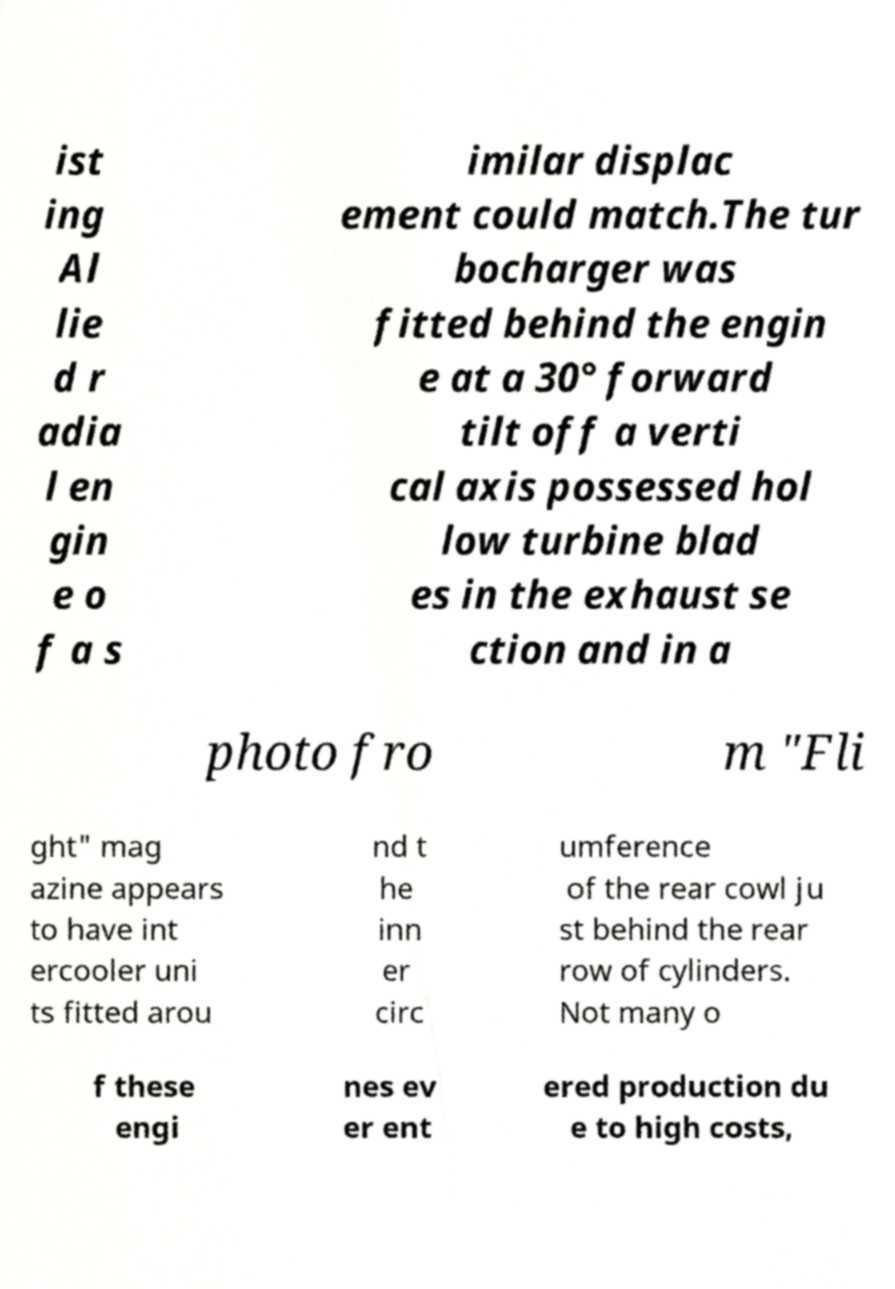Can you read and provide the text displayed in the image?This photo seems to have some interesting text. Can you extract and type it out for me? ist ing Al lie d r adia l en gin e o f a s imilar displac ement could match.The tur bocharger was fitted behind the engin e at a 30° forward tilt off a verti cal axis possessed hol low turbine blad es in the exhaust se ction and in a photo fro m "Fli ght" mag azine appears to have int ercooler uni ts fitted arou nd t he inn er circ umference of the rear cowl ju st behind the rear row of cylinders. Not many o f these engi nes ev er ent ered production du e to high costs, 